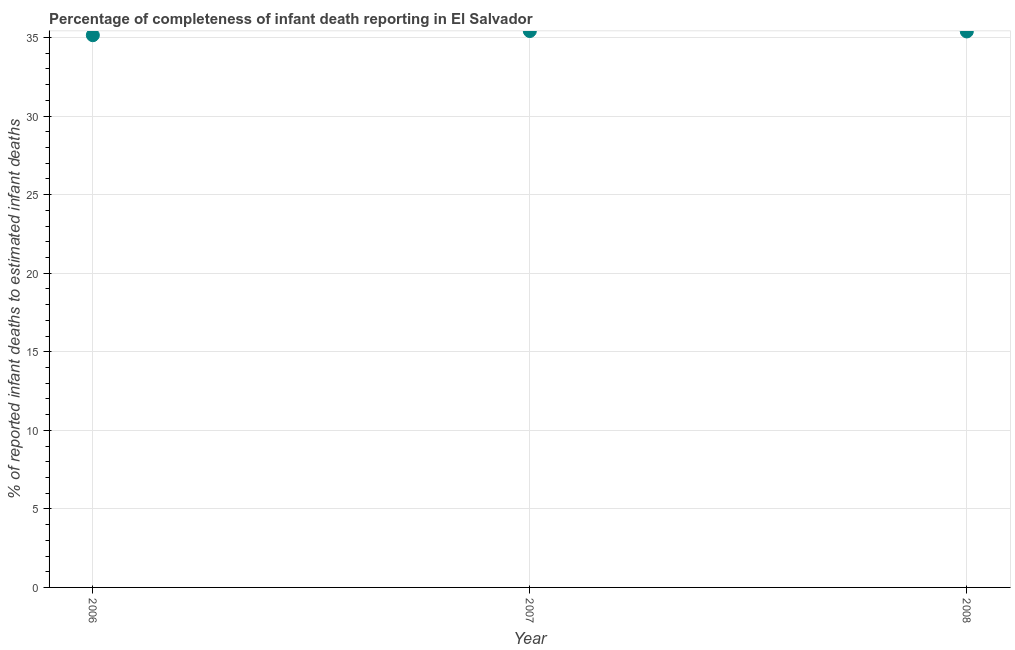What is the completeness of infant death reporting in 2006?
Make the answer very short. 35.15. Across all years, what is the maximum completeness of infant death reporting?
Offer a terse response. 35.42. Across all years, what is the minimum completeness of infant death reporting?
Your answer should be compact. 35.15. In which year was the completeness of infant death reporting minimum?
Give a very brief answer. 2006. What is the sum of the completeness of infant death reporting?
Your response must be concise. 105.95. What is the difference between the completeness of infant death reporting in 2007 and 2008?
Ensure brevity in your answer.  0.03. What is the average completeness of infant death reporting per year?
Offer a very short reply. 35.32. What is the median completeness of infant death reporting?
Your answer should be very brief. 35.39. Do a majority of the years between 2006 and 2008 (inclusive) have completeness of infant death reporting greater than 25 %?
Your answer should be very brief. Yes. What is the ratio of the completeness of infant death reporting in 2006 to that in 2007?
Keep it short and to the point. 0.99. Is the completeness of infant death reporting in 2006 less than that in 2007?
Provide a short and direct response. Yes. Is the difference between the completeness of infant death reporting in 2006 and 2007 greater than the difference between any two years?
Your answer should be compact. Yes. What is the difference between the highest and the second highest completeness of infant death reporting?
Your answer should be very brief. 0.03. What is the difference between the highest and the lowest completeness of infant death reporting?
Your response must be concise. 0.27. Does the completeness of infant death reporting monotonically increase over the years?
Offer a very short reply. No. What is the title of the graph?
Make the answer very short. Percentage of completeness of infant death reporting in El Salvador. What is the label or title of the X-axis?
Offer a very short reply. Year. What is the label or title of the Y-axis?
Make the answer very short. % of reported infant deaths to estimated infant deaths. What is the % of reported infant deaths to estimated infant deaths in 2006?
Offer a very short reply. 35.15. What is the % of reported infant deaths to estimated infant deaths in 2007?
Offer a very short reply. 35.42. What is the % of reported infant deaths to estimated infant deaths in 2008?
Make the answer very short. 35.39. What is the difference between the % of reported infant deaths to estimated infant deaths in 2006 and 2007?
Your answer should be compact. -0.27. What is the difference between the % of reported infant deaths to estimated infant deaths in 2006 and 2008?
Ensure brevity in your answer.  -0.24. What is the difference between the % of reported infant deaths to estimated infant deaths in 2007 and 2008?
Ensure brevity in your answer.  0.03. What is the ratio of the % of reported infant deaths to estimated infant deaths in 2006 to that in 2008?
Your answer should be very brief. 0.99. What is the ratio of the % of reported infant deaths to estimated infant deaths in 2007 to that in 2008?
Provide a short and direct response. 1. 